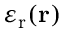Convert formula to latex. <formula><loc_0><loc_0><loc_500><loc_500>\varepsilon _ { r } ( { r } )</formula> 